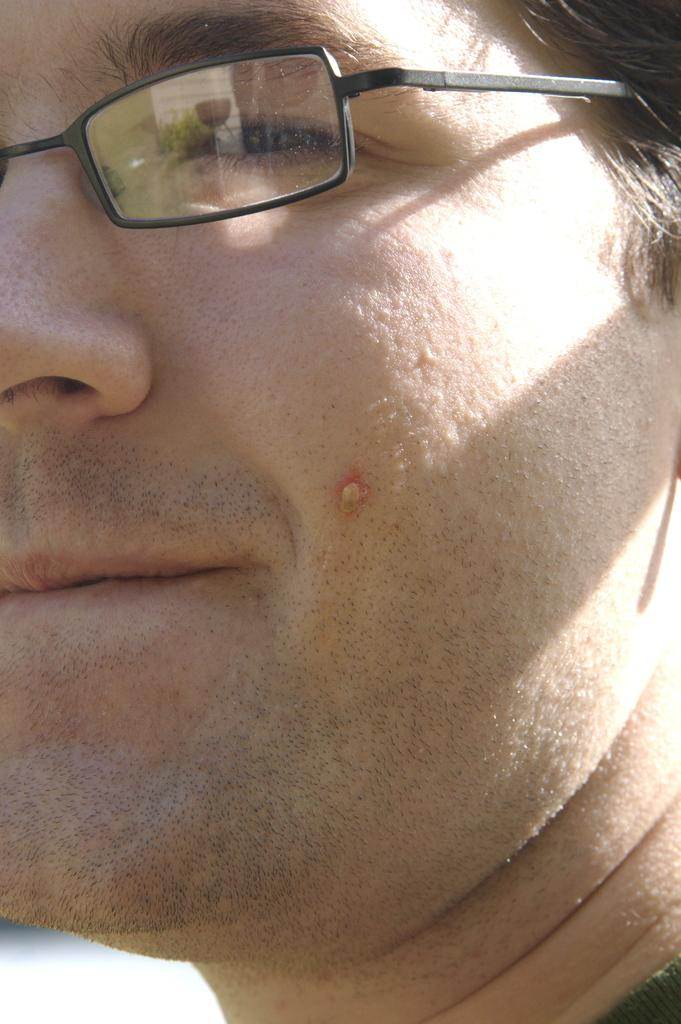What is the main subject of the image? There is a person in the image. Can you describe the person's appearance? The person is wearing spectacles. What is the color of the background in the image? The background of the image is white in color. What type of argument is the person having with the ducks in the image? There are no ducks present in the image, so there can be no argument with them. 